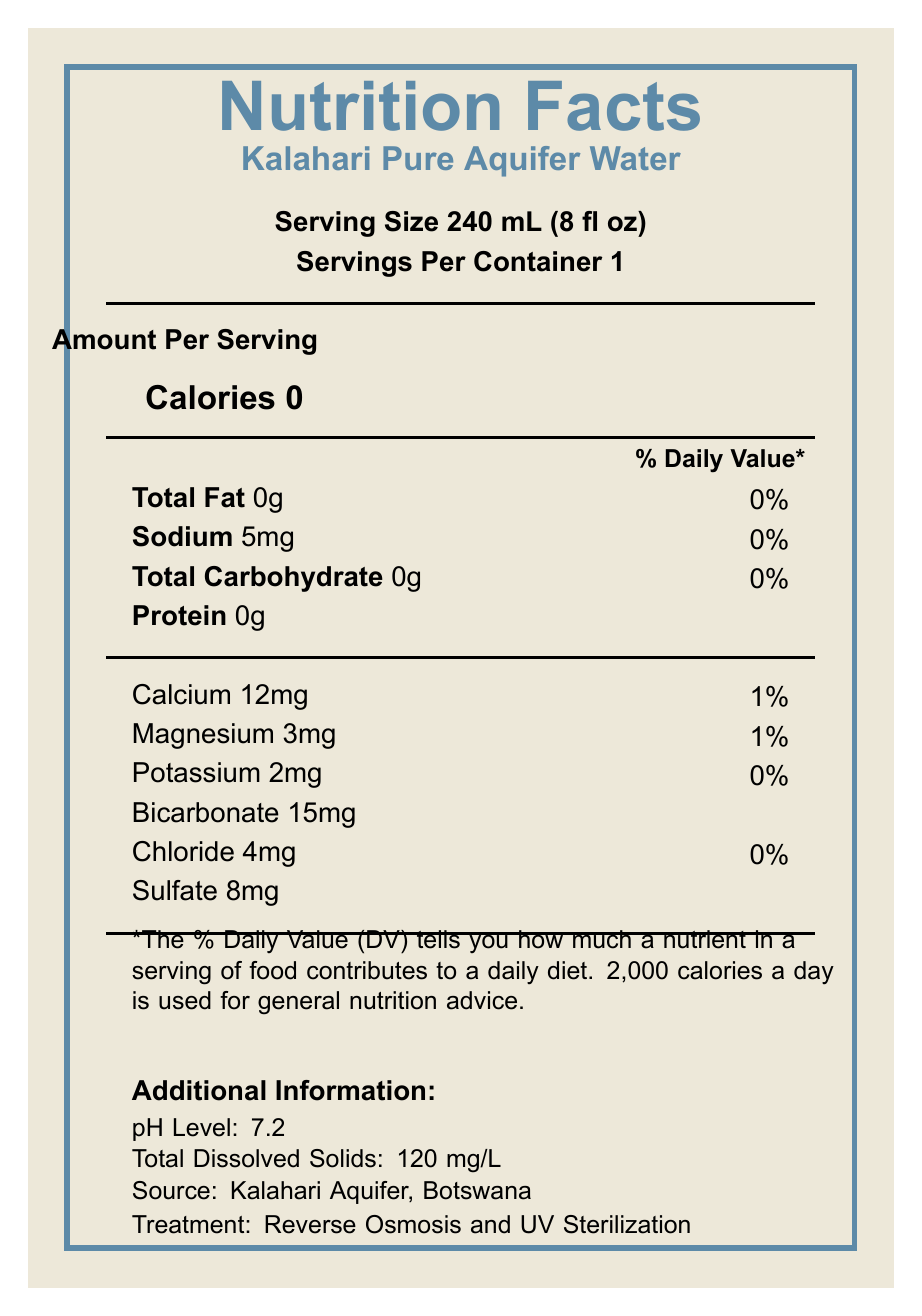what is the pH level of the water? The document lists the pH level of Kalahari Pure Aquifer Water as 7.2.
Answer: 7.2 what is the amount of sodium in each serving? The Nutrition Facts Label specifies that there are 5mg of sodium per serving.
Answer: 5mg name two minerals found in the bottled water. According to the Nutrition Facts Label, Calcium and Magnesium are among the minerals found in Kalahari Pure Aquifer Water.
Answer: Calcium, Magnesium where is the bottled water sourced from? The document states that the source of the water is the Kalahari Aquifer in Botswana.
Answer: Kalahari Aquifer, Botswana what is the serving size of the bottled water? The serving size is shown as 240 mL (8 fl oz) on the Nutrition Facts Label.
Answer: 240 mL (8 fl oz) how many calories are in the bottled water? The Nutrition Facts Label plainly indicates that there are 0 calories in the water.
Answer: 0 what is the main treatment process used for the water? A. Boiling B. UV Sterilization C. Chlorination D. Reverse Osmosis and UV Sterilization The document states that the water undergoes "Reverse Osmosis and UV Sterilization."
Answer: D which mineral has the highest daily value percentage? A. Calcium B. Magnesium C. Potassium D. Chloride Calcium has the highest daily value percentage at 1%, as shown on the Nutrition Facts Label.
Answer: A is the bottled water certified by any regulatory body? The document mentions that the water is certified by the Botswana Bureau of Standards (BOBS).
Answer: Yes summarize the main attributes of Kalahari Pure Aquifer Water. The document details the nutritional content, mineral composition, pH level, and treatment process of the water, along with information about its source and certification.
Answer: Kalahari Pure Aquifer Water is sourced from the Kalahari Aquifer in Botswana. It contains 0 calories, 5mg of sodium, and various minerals like Calcium, Magnesium, and Potassium. The water, which has a pH level of 7.2 and total dissolved solids of 120 mg/L, undergoes Reverse Osmosis and UV Sterilization. It is bottled in recycled PET plastic and is BOBS certified. what is the total carbohydrate content per serving? The document states a total carbohydrate content of 0g per serving.
Answer: 0g are there any calories in each serving? The Nutrition Facts Label indicates that there are 0 calories per serving.
Answer: No how deep is the aquifer from which the water is sourced? According to the document, the aquifer is 200 meters deep.
Answer: 200 meters what is the water age according to the additional information? The document states that the water is approximately 10,000 years old.
Answer: Approximately 10,000 years old how many servings are in the container? The Nutrition Facts Label specifies that there is 1 serving per container.
Answer: 1 how much potassium is there in the bottled water? The document specifies that there are 2mg of potassium in each serving.
Answer: 2mg what is the location of the bottling operation for this water? The document mentions that the bottling location is Gaborone, Botswana.
Answer: Gaborone, Botswana does the document provide any information about the price of the bottled water? The document does not include any details about the price of the bottled water.
Answer: I don't know 